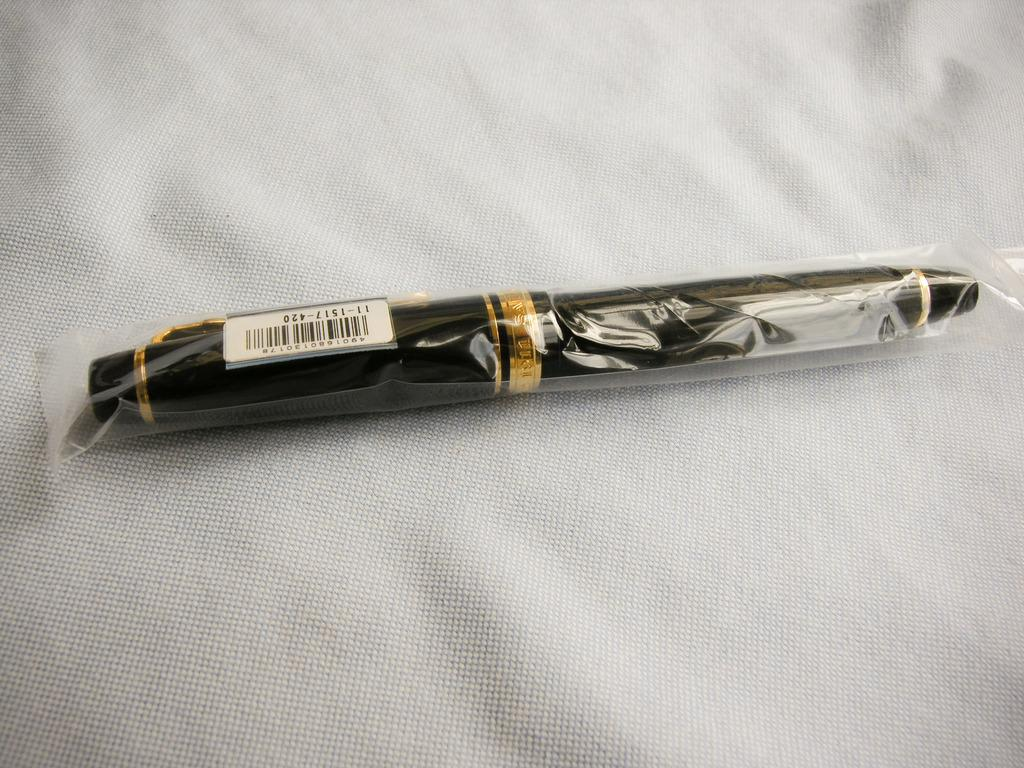What object can be seen in the image? There is a pen in the image. Where is the pen located? The pen is placed on a cloth. What is the purpose of the sticks in the image? There are no sticks present in the image, so it is not possible to determine their purpose. 